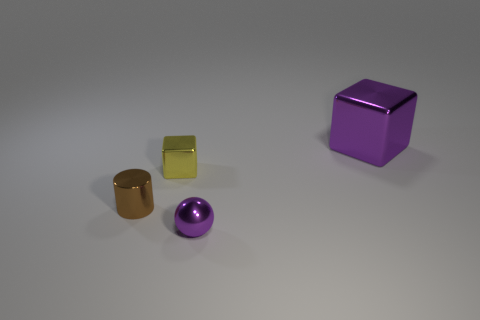Add 3 purple objects. How many objects exist? 7 Subtract 1 balls. How many balls are left? 0 Subtract all balls. How many objects are left? 3 Subtract all metallic cylinders. Subtract all spheres. How many objects are left? 2 Add 2 large purple metal objects. How many large purple metal objects are left? 3 Add 1 big gray rubber cylinders. How many big gray rubber cylinders exist? 1 Subtract 0 red balls. How many objects are left? 4 Subtract all red cylinders. Subtract all yellow blocks. How many cylinders are left? 1 